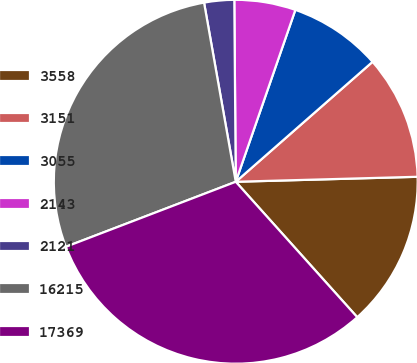Convert chart to OTSL. <chart><loc_0><loc_0><loc_500><loc_500><pie_chart><fcel>3558<fcel>3151<fcel>3055<fcel>2143<fcel>2121<fcel>16215<fcel>17369<nl><fcel>13.8%<fcel>11.02%<fcel>8.23%<fcel>5.44%<fcel>2.66%<fcel>28.03%<fcel>30.82%<nl></chart> 